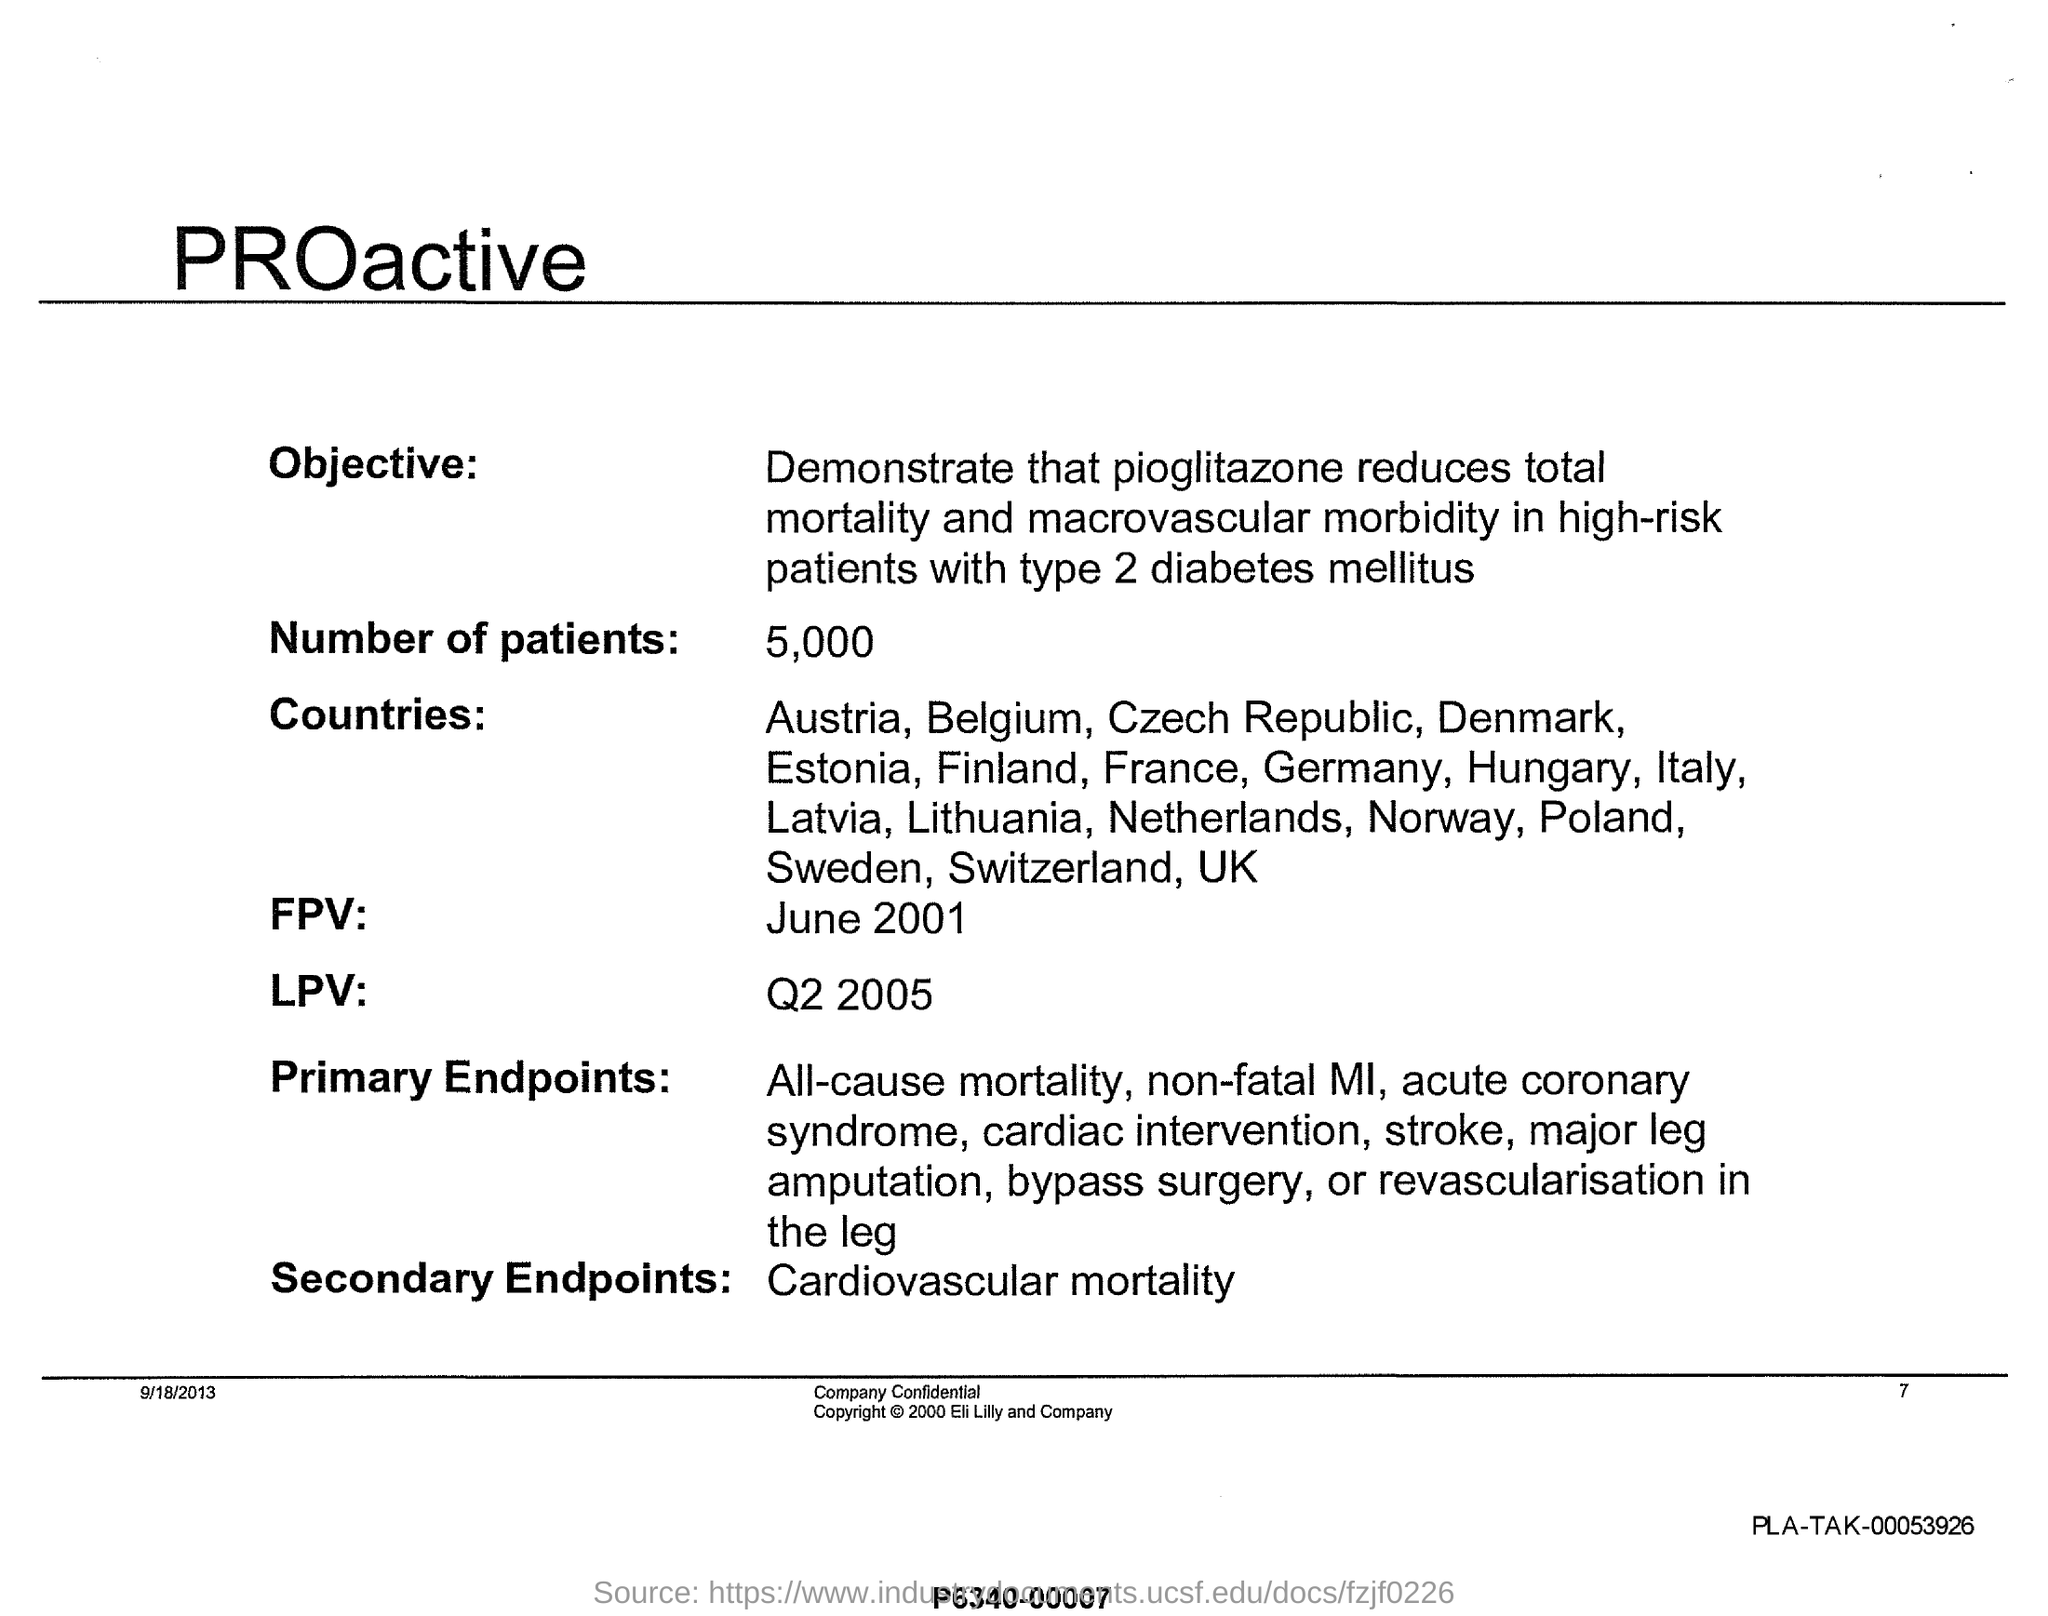Specify some key components in this picture. As of June 2001, the term "FPV" refers to a specific type of technology or concept, but its definition and scope are not yet fully established. There are approximately 5,000 patients. Secondary endpoints refer to the outcomes that are measured in addition to the primary endpoint in a clinical trial. In the context of cardiovascular mortality, secondary endpoints may include measures such as all-cause mortality, cardiovascular events, and other relevant clinical outcomes. Understanding and accurately analyzing secondary endpoints can provide valuable insights into the safety and efficacy of a treatment or intervention. 